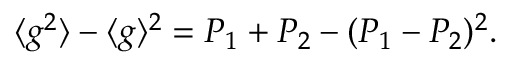Convert formula to latex. <formula><loc_0><loc_0><loc_500><loc_500>{ \langle g ^ { 2 } \rangle - \langle g \rangle ^ { 2 } = P _ { 1 } + P _ { 2 } - ( P _ { 1 } - P _ { 2 } ) ^ { 2 } } .</formula> 